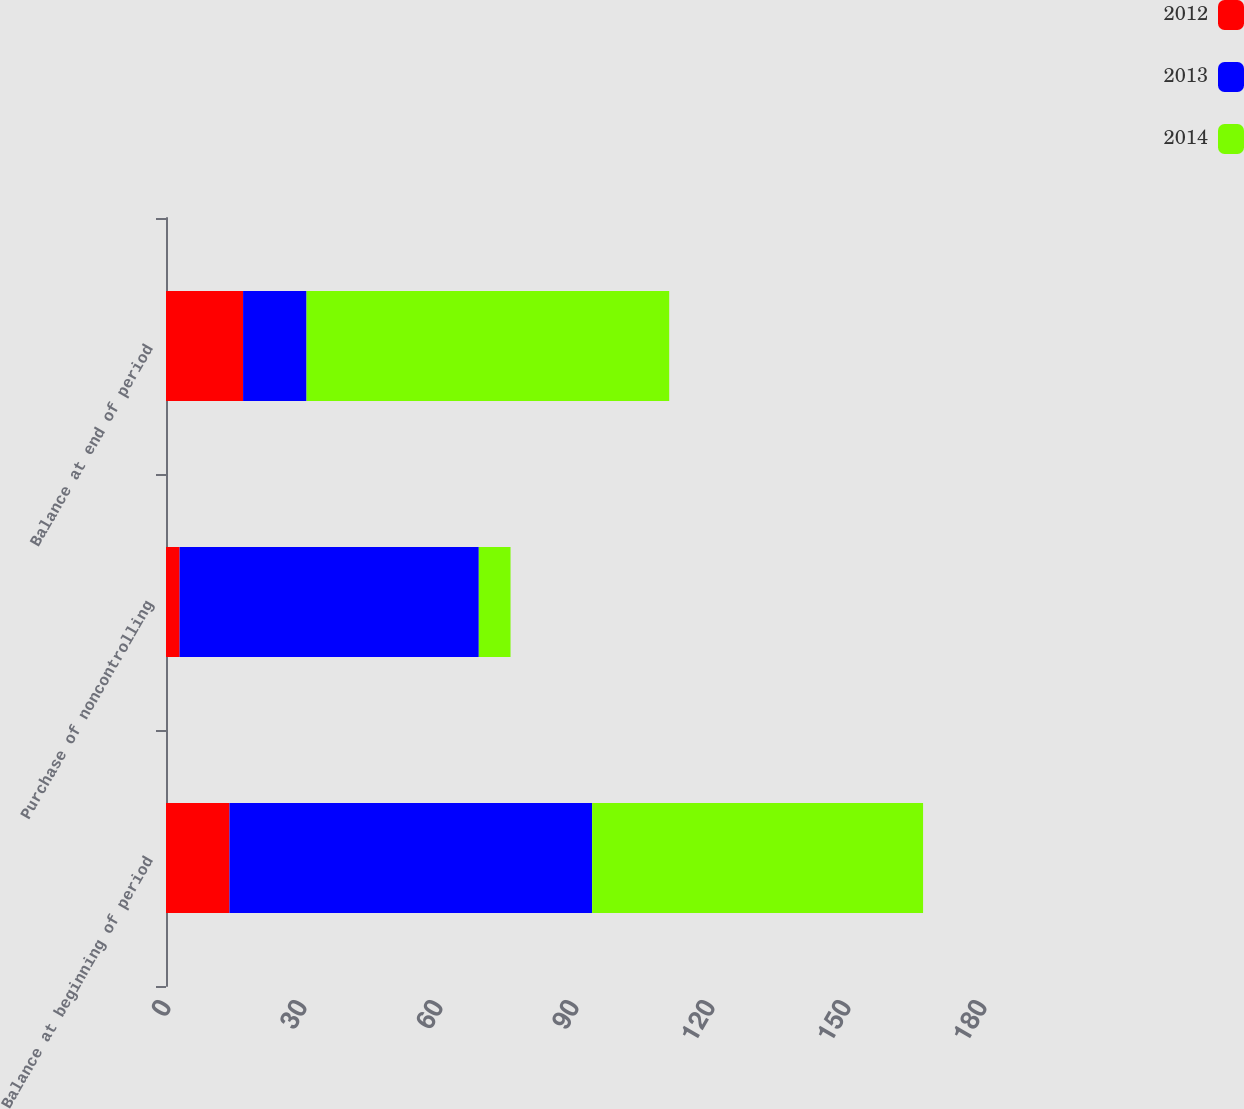Convert chart to OTSL. <chart><loc_0><loc_0><loc_500><loc_500><stacked_bar_chart><ecel><fcel>Balance at beginning of period<fcel>Purchase of noncontrolling<fcel>Balance at end of period<nl><fcel>2012<fcel>14<fcel>3<fcel>17<nl><fcel>2013<fcel>80<fcel>66<fcel>14<nl><fcel>2014<fcel>73<fcel>7<fcel>80<nl></chart> 